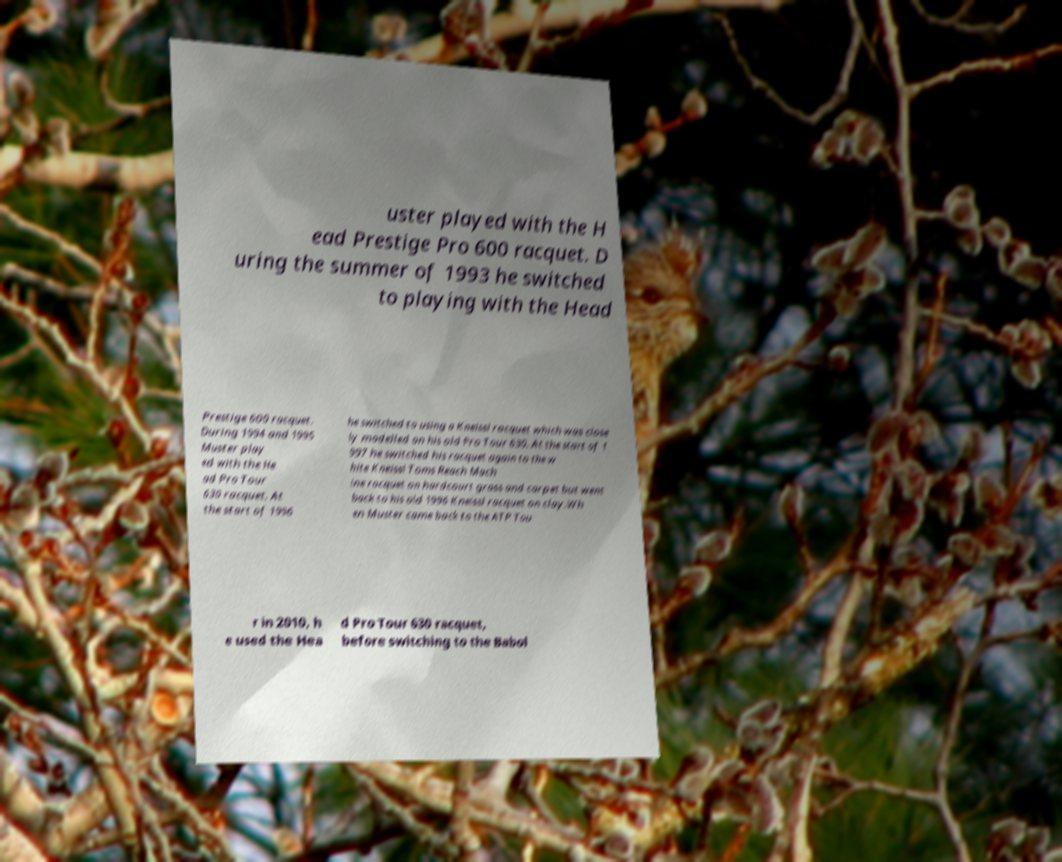Could you assist in decoding the text presented in this image and type it out clearly? uster played with the H ead Prestige Pro 600 racquet. D uring the summer of 1993 he switched to playing with the Head Prestige 600 racquet. During 1994 and 1995 Muster play ed with the He ad Pro Tour 630 racquet. At the start of 1996 he switched to using a Kneissl racquet which was close ly modelled on his old Pro Tour 630. At the start of 1 997 he switched his racquet again to the w hite Kneissl Toms Reach Mach ine racquet on hardcourt grass and carpet but went back to his old 1996 Kneissl racquet on clay.Wh en Muster came back to the ATP Tou r in 2010, h e used the Hea d Pro Tour 630 racquet, before switching to the Babol 